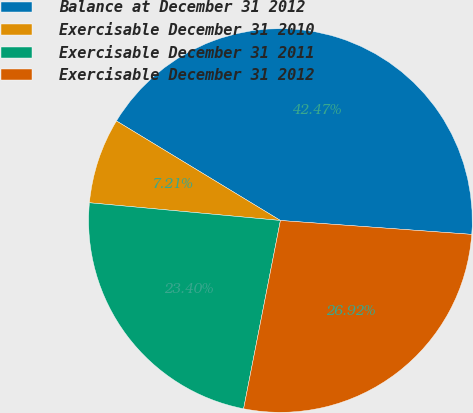Convert chart to OTSL. <chart><loc_0><loc_0><loc_500><loc_500><pie_chart><fcel>Balance at December 31 2012<fcel>Exercisable December 31 2010<fcel>Exercisable December 31 2011<fcel>Exercisable December 31 2012<nl><fcel>42.47%<fcel>7.21%<fcel>23.4%<fcel>26.92%<nl></chart> 